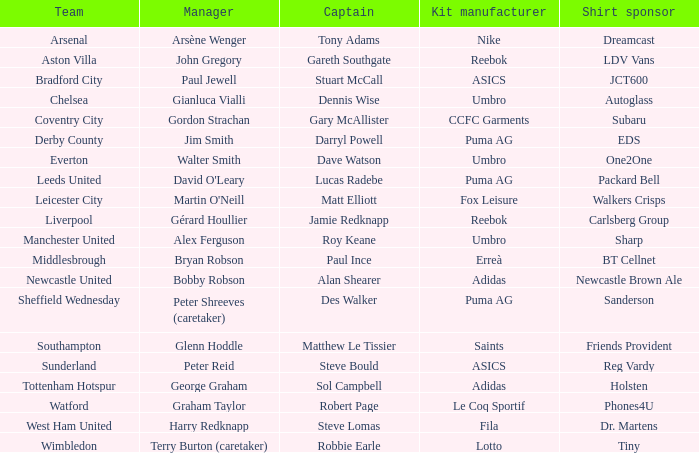Which captain is managed by gianluca vialli? Dennis Wise. 